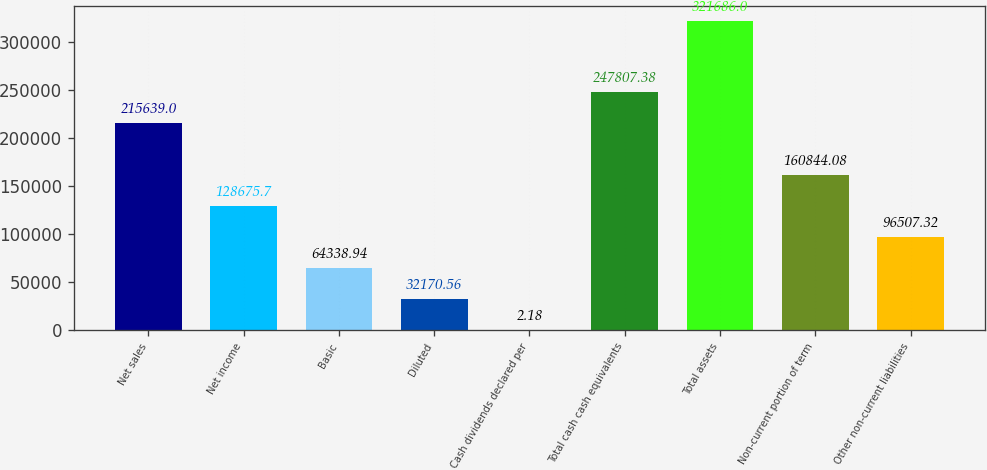Convert chart to OTSL. <chart><loc_0><loc_0><loc_500><loc_500><bar_chart><fcel>Net sales<fcel>Net income<fcel>Basic<fcel>Diluted<fcel>Cash dividends declared per<fcel>Total cash cash equivalents<fcel>Total assets<fcel>Non-current portion of term<fcel>Other non-current liabilities<nl><fcel>215639<fcel>128676<fcel>64338.9<fcel>32170.6<fcel>2.18<fcel>247807<fcel>321686<fcel>160844<fcel>96507.3<nl></chart> 